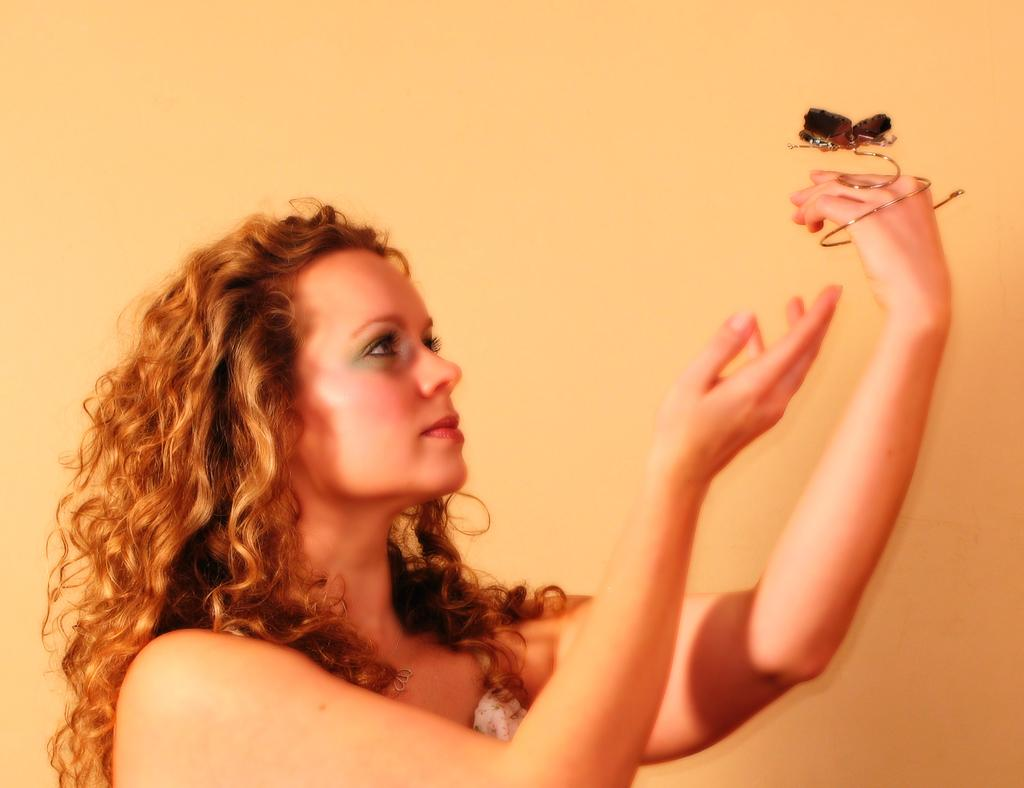What can be seen in the image? There is a person in the image. What is the person doing in the image? The person is holding an object. What is visible in the background of the image? There is a wall in the background of the image. How many babies are present in the image? There is no baby present in the image; it features a person holding an object. What type of hope can be seen in the image? There is no representation of hope in the image; it only shows a person holding an object with a wall in the background. 